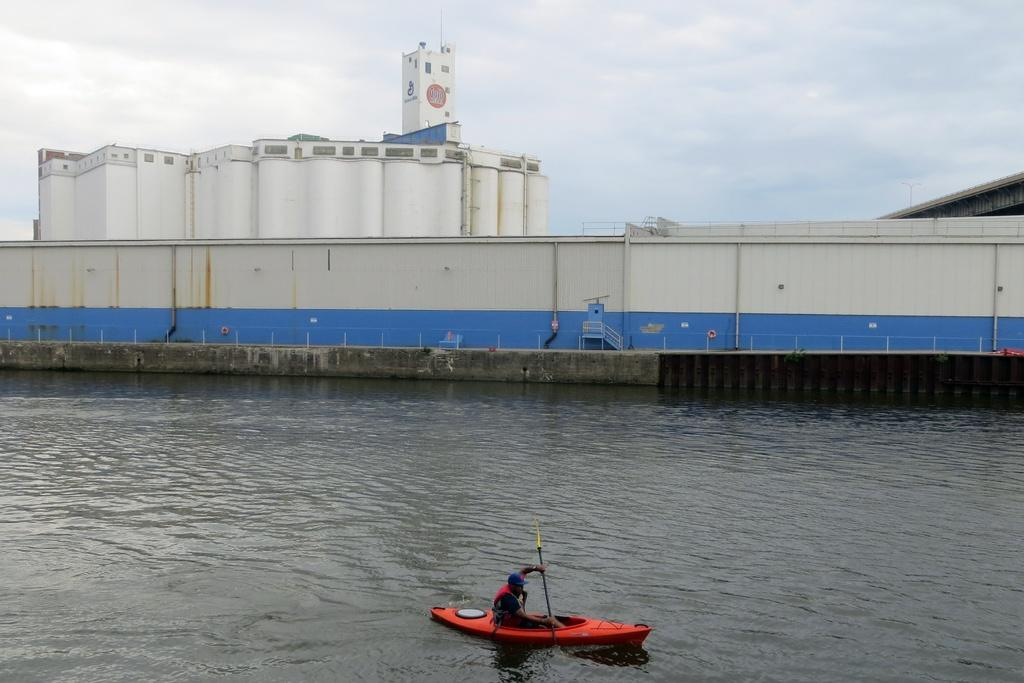What is the person in the image doing? The person is sitting in a boat and sailing on the water. What can be seen in the background of the image? There is a building in the background of the image. What is the condition of the sky in the image? The sky is clear in the image. What type of prose is being recited by the person in the boat? There is no indication in the image that the person is reciting any prose. Can you see any plantation in the image? There is no plantation visible in the image. 